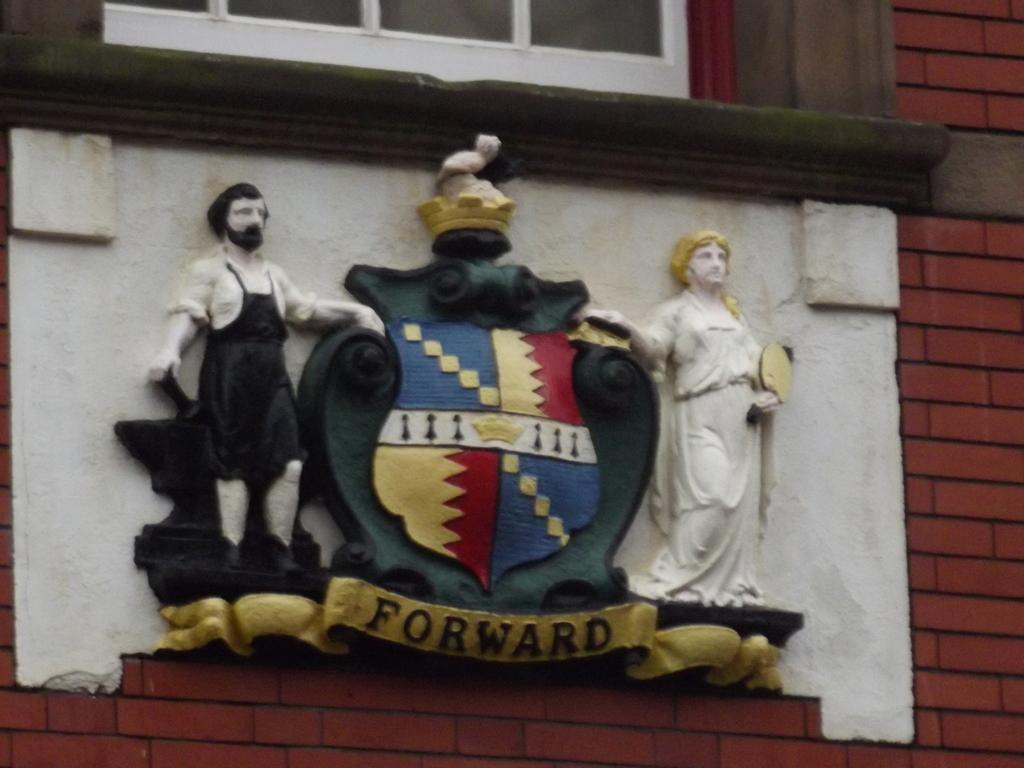Where was the image taken? The image was taken outdoors. What can be seen in the background of the image? There is a building in the image. What feature of the building is visible? The building has a wall. What is on the wall? There is a sculpture of two men on the wall. What is special about the sculpture? The sculpture has a symbol and text on it. What type of potato is being used as a quill by the grandfather in the image? There is no potato, quill, or grandfather present in the image. 